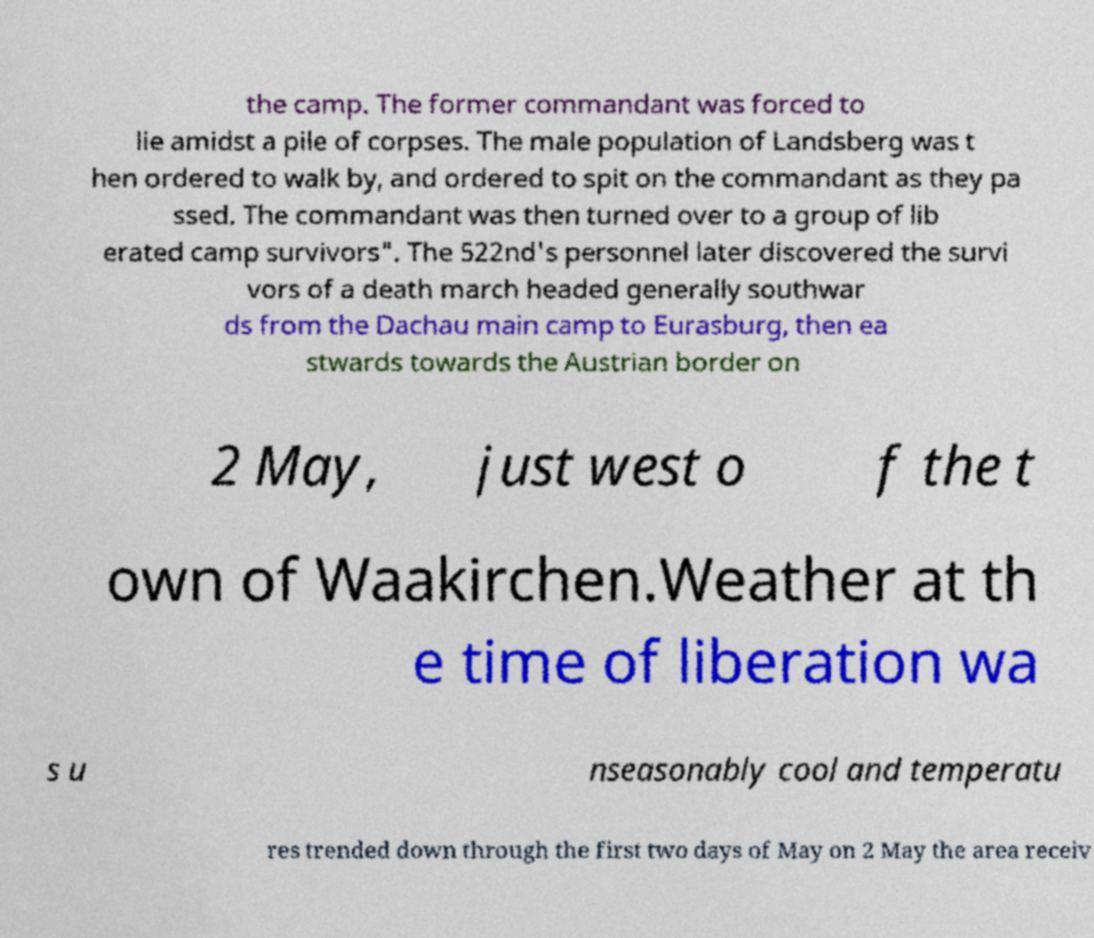Can you read and provide the text displayed in the image?This photo seems to have some interesting text. Can you extract and type it out for me? the camp. The former commandant was forced to lie amidst a pile of corpses. The male population of Landsberg was t hen ordered to walk by, and ordered to spit on the commandant as they pa ssed. The commandant was then turned over to a group of lib erated camp survivors". The 522nd's personnel later discovered the survi vors of a death march headed generally southwar ds from the Dachau main camp to Eurasburg, then ea stwards towards the Austrian border on 2 May, just west o f the t own of Waakirchen.Weather at th e time of liberation wa s u nseasonably cool and temperatu res trended down through the first two days of May on 2 May the area receiv 